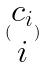<formula> <loc_0><loc_0><loc_500><loc_500>( \begin{matrix} c _ { i } \\ i \end{matrix} )</formula> 